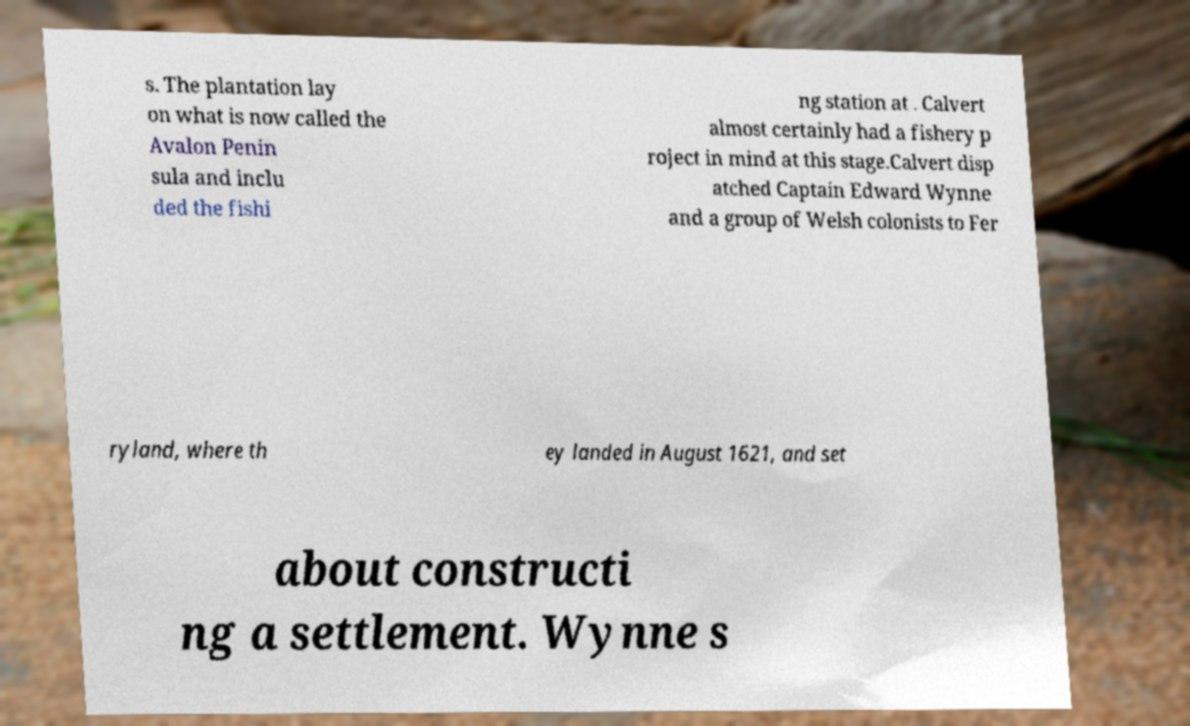I need the written content from this picture converted into text. Can you do that? s. The plantation lay on what is now called the Avalon Penin sula and inclu ded the fishi ng station at . Calvert almost certainly had a fishery p roject in mind at this stage.Calvert disp atched Captain Edward Wynne and a group of Welsh colonists to Fer ryland, where th ey landed in August 1621, and set about constructi ng a settlement. Wynne s 